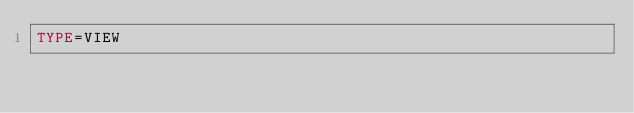Convert code to text. <code><loc_0><loc_0><loc_500><loc_500><_VisualBasic_>TYPE=VIEW</code> 